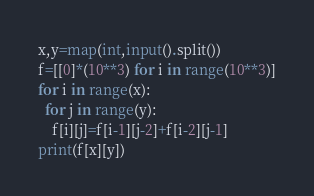<code> <loc_0><loc_0><loc_500><loc_500><_Python_>x,y=map(int,input().split())
f=[[0]*(10**3) for i in range(10**3)]
for i in range(x):
  for j in range(y):
    f[i][j]=f[i-1][j-2]+f[i-2][j-1]
print(f[x][y])</code> 